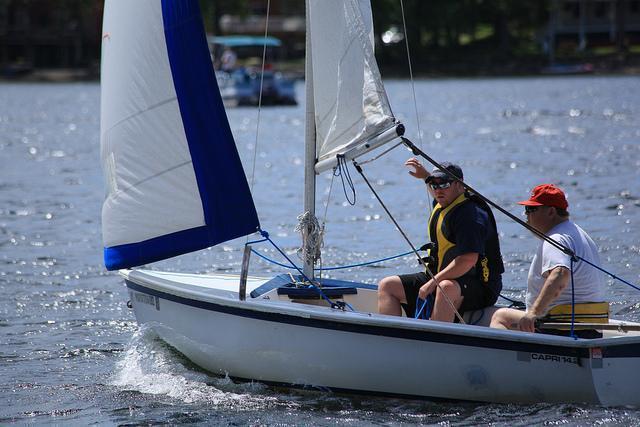What color is the border of the sail on the small boat?
Choose the correct response, then elucidate: 'Answer: answer
Rationale: rationale.'
Options: Yellow, red, blue, green. Answer: blue.
Rationale: The leftmost sail in this image has a blue outline. 